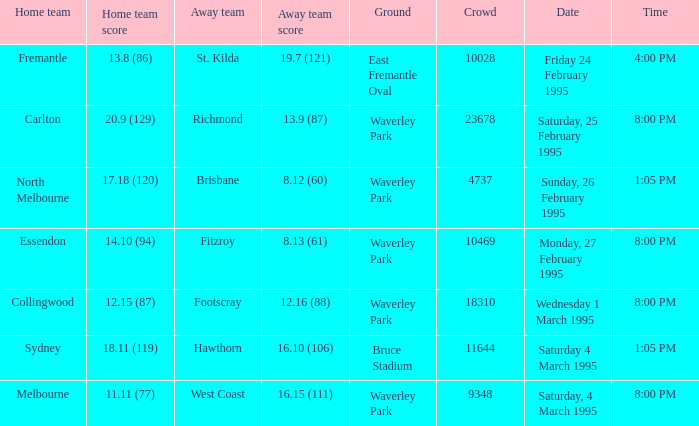What is the overall number of grounds associated with essendon? 1.0. 